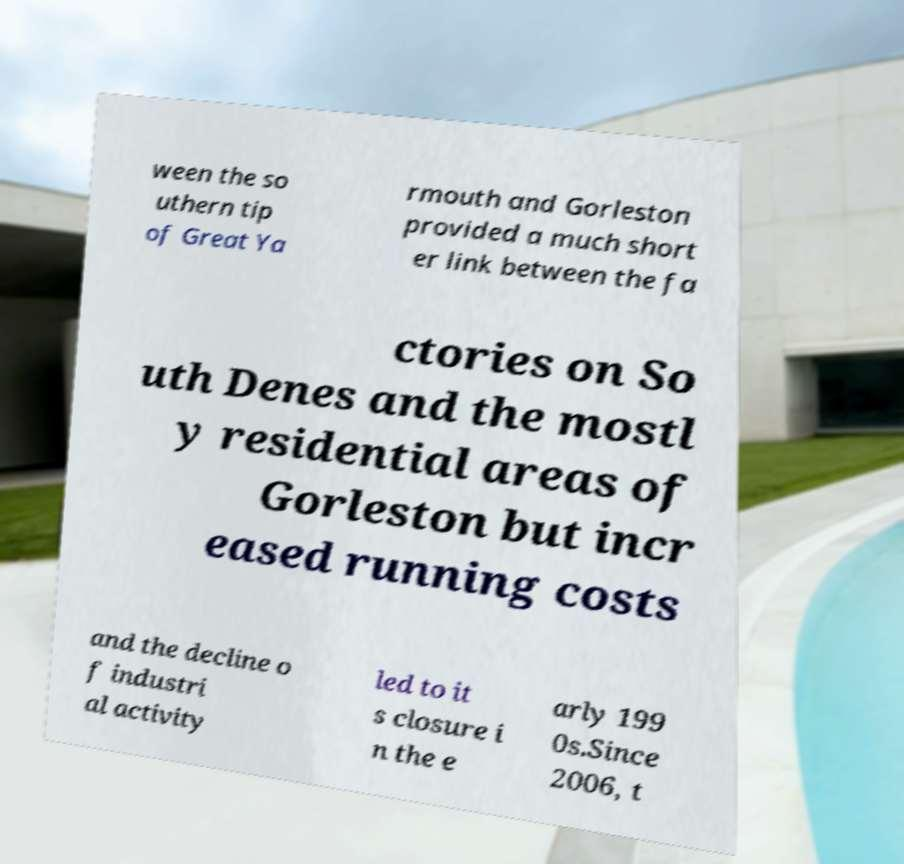I need the written content from this picture converted into text. Can you do that? ween the so uthern tip of Great Ya rmouth and Gorleston provided a much short er link between the fa ctories on So uth Denes and the mostl y residential areas of Gorleston but incr eased running costs and the decline o f industri al activity led to it s closure i n the e arly 199 0s.Since 2006, t 